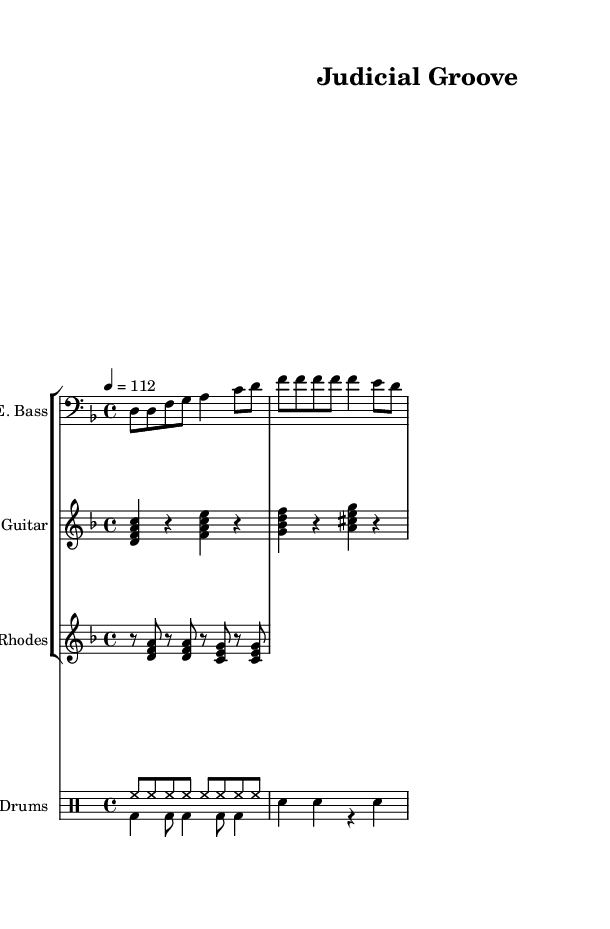What is the key signature of this music? The key signature is D minor, which has one flat (B flat). This can be identified by looking at the key signature at the beginning of the sheet music where the symbol for B flat is present.
Answer: D minor What is the time signature of this music? The time signature is 4/4, which indicates there are four beats in a measure and the quarter note gets one beat. This can be found at the start of the music, right after the key signature.
Answer: 4/4 What is the tempo marking of this music? The tempo marking indicates a speed of 112 beats per minute (BPM) as specified under the tempo instruction in the global settings. This gives an idea of how fast the music should be played.
Answer: 112 How many measures does the drum pattern typically include? The drum pattern consists of a total of 6 measures combined between the hi-hat and bass drum patterns, creating a full groove. This can be counted by looking at the drum staff and identifying the measure lines.
Answer: 6 measures What instruments are featured in this composition? The instruments featured include Electric Bass, Electric Guitar, Rhodes Piano, and Drums, each of which is labeled at the beginning of their respective staves in the score.
Answer: Electric Bass, Electric Guitar, Rhodes Piano, Drums Which chord is played by the electric guitar in the first measure? The electric guitar plays the D minor chord (D, F, A) in the first measure, identifiable by the note heads placed on the staff indicating those specific pitches simultaneously.
Answer: D minor 